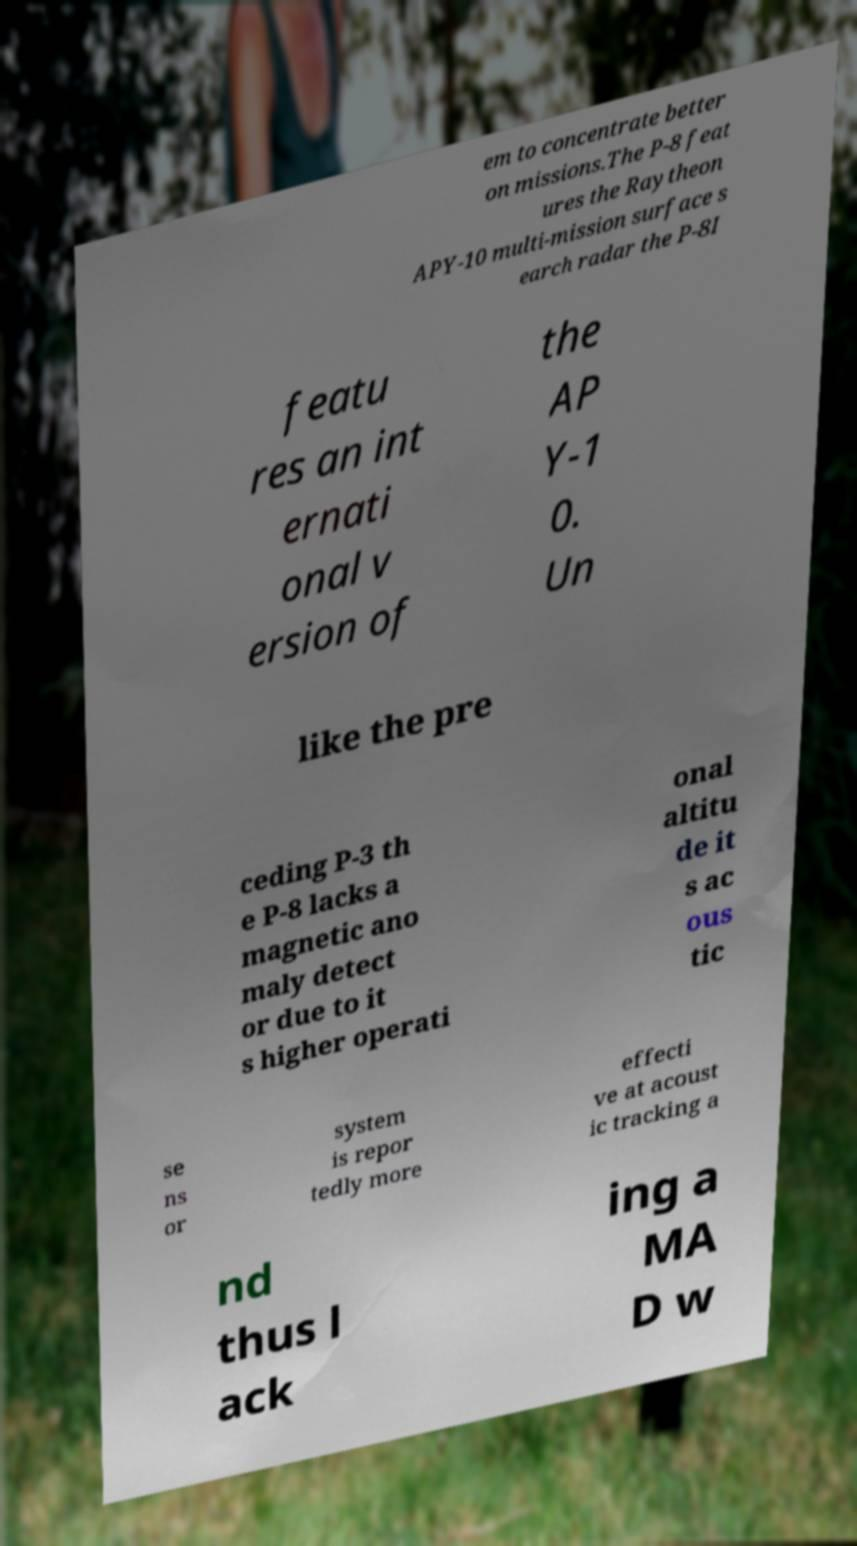Could you assist in decoding the text presented in this image and type it out clearly? em to concentrate better on missions.The P-8 feat ures the Raytheon APY-10 multi-mission surface s earch radar the P-8I featu res an int ernati onal v ersion of the AP Y-1 0. Un like the pre ceding P-3 th e P-8 lacks a magnetic ano maly detect or due to it s higher operati onal altitu de it s ac ous tic se ns or system is repor tedly more effecti ve at acoust ic tracking a nd thus l ack ing a MA D w 